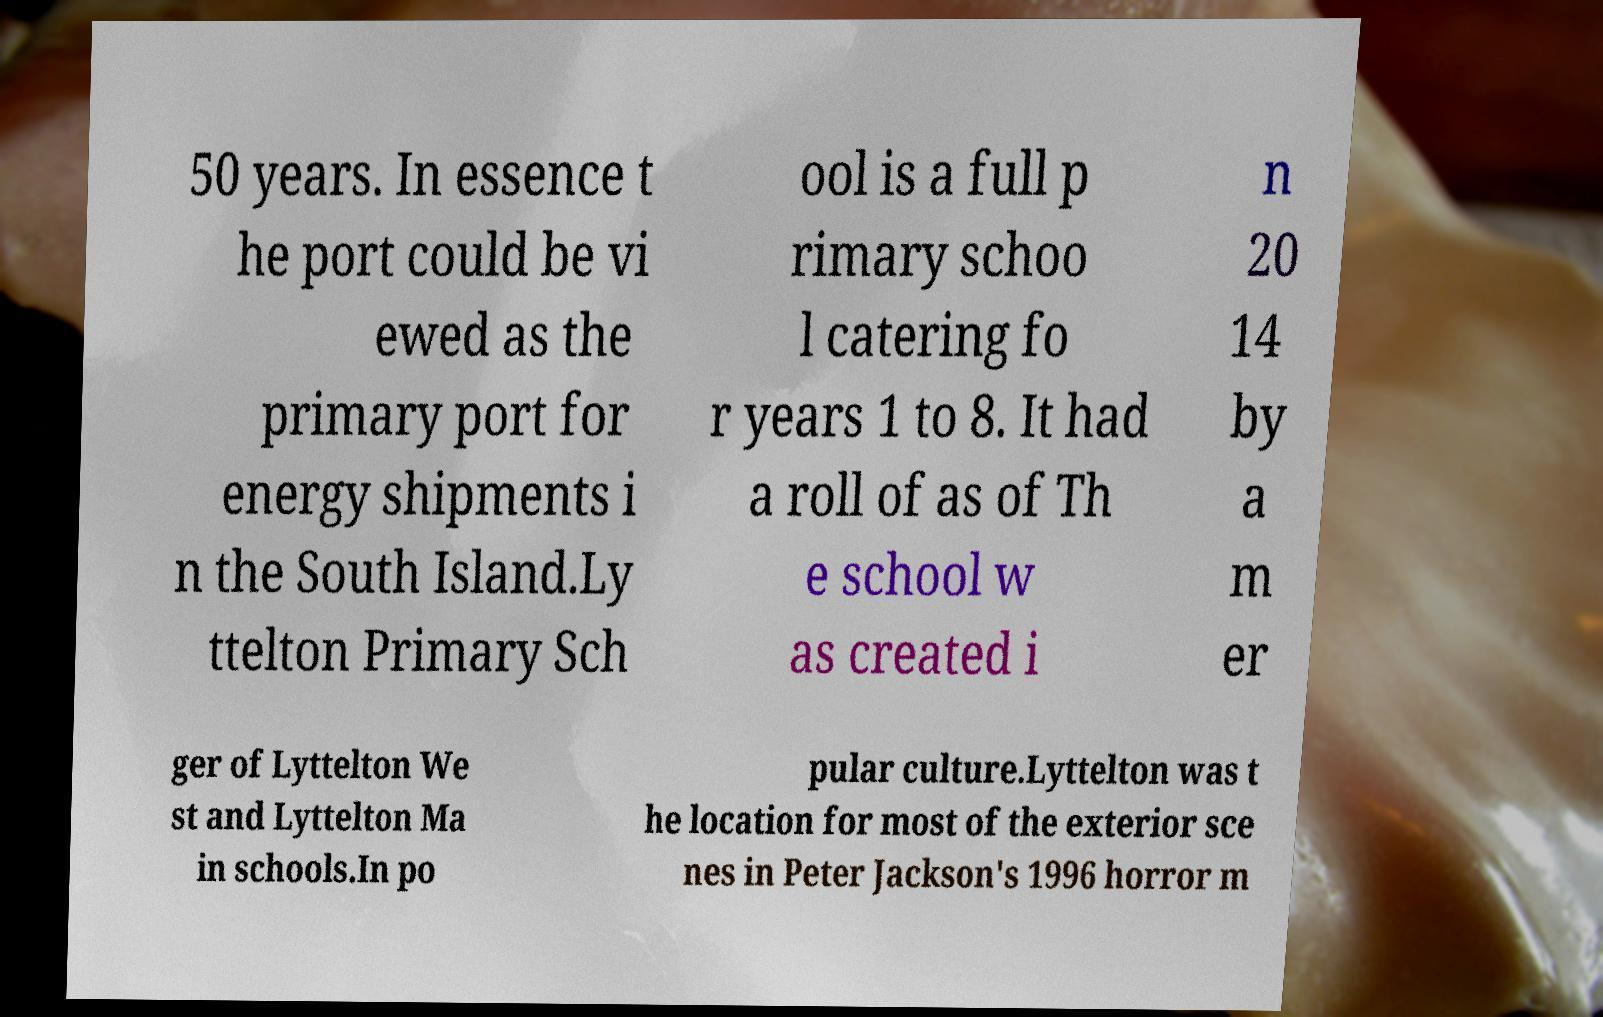What messages or text are displayed in this image? I need them in a readable, typed format. 50 years. In essence t he port could be vi ewed as the primary port for energy shipments i n the South Island.Ly ttelton Primary Sch ool is a full p rimary schoo l catering fo r years 1 to 8. It had a roll of as of Th e school w as created i n 20 14 by a m er ger of Lyttelton We st and Lyttelton Ma in schools.In po pular culture.Lyttelton was t he location for most of the exterior sce nes in Peter Jackson's 1996 horror m 